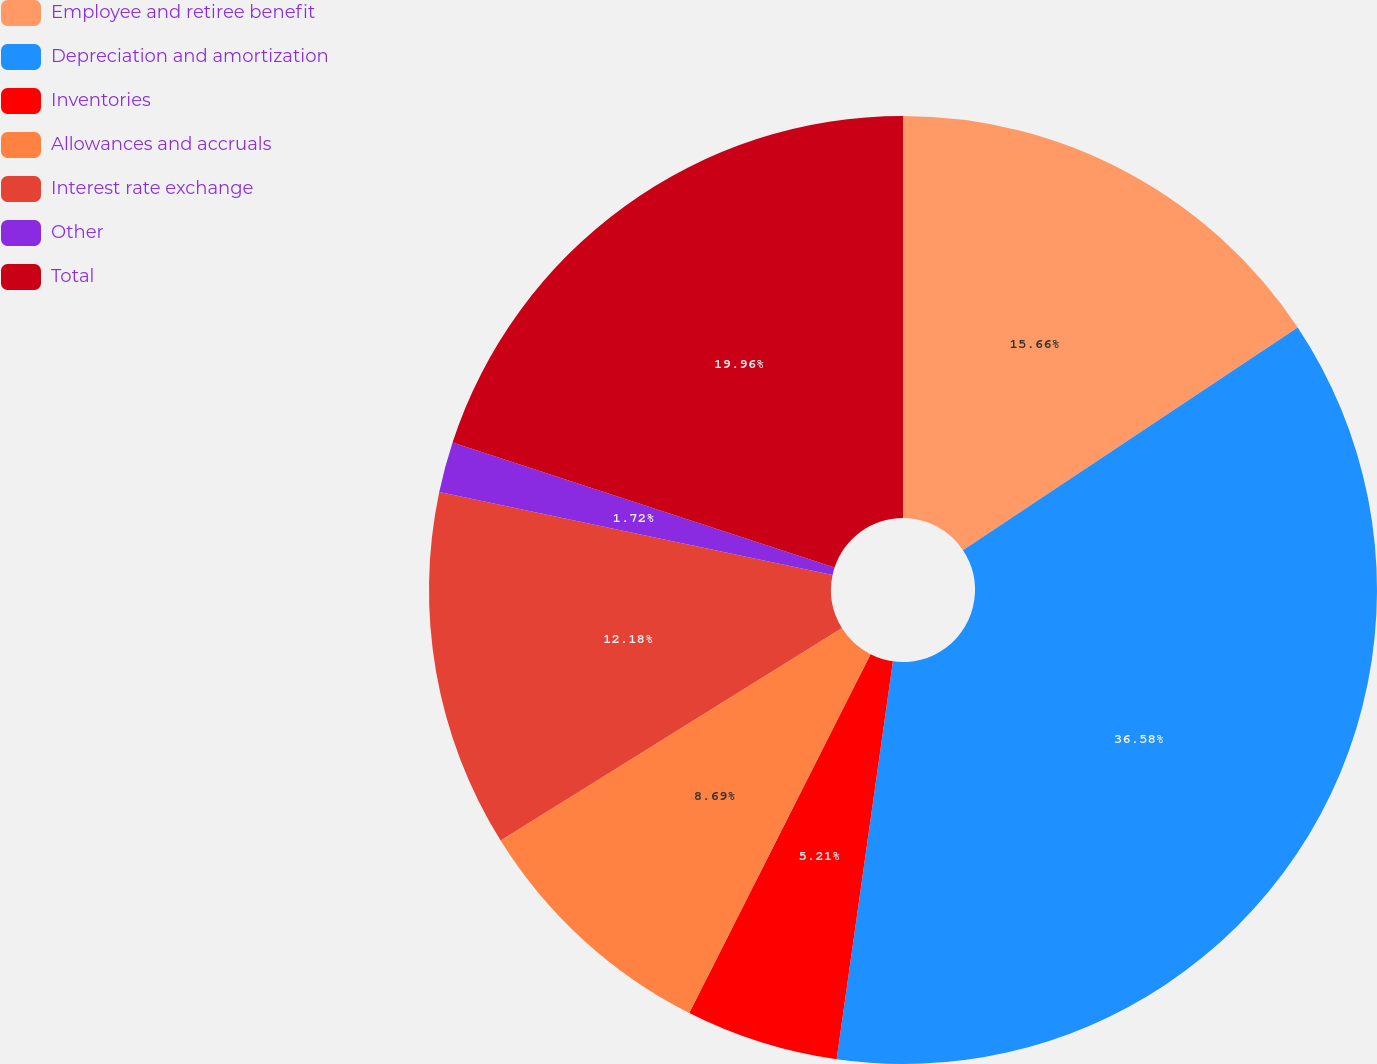Convert chart. <chart><loc_0><loc_0><loc_500><loc_500><pie_chart><fcel>Employee and retiree benefit<fcel>Depreciation and amortization<fcel>Inventories<fcel>Allowances and accruals<fcel>Interest rate exchange<fcel>Other<fcel>Total<nl><fcel>15.66%<fcel>36.57%<fcel>5.21%<fcel>8.69%<fcel>12.18%<fcel>1.72%<fcel>19.96%<nl></chart> 